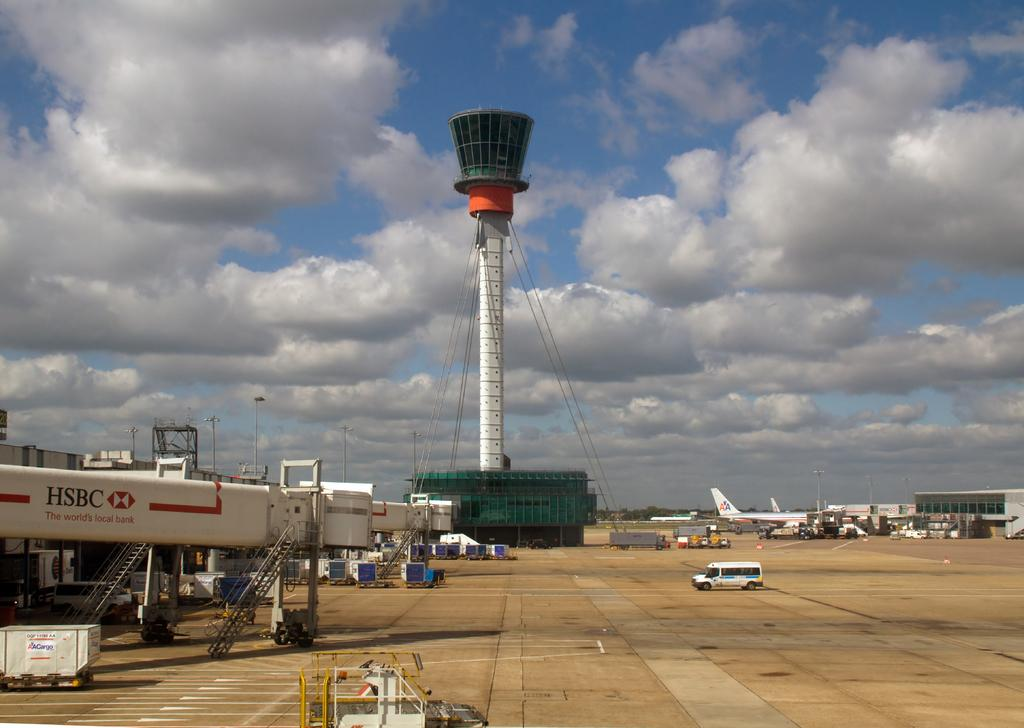Provide a one-sentence caption for the provided image. The HSBC bank name is visible on several pieces of airport equipment. 